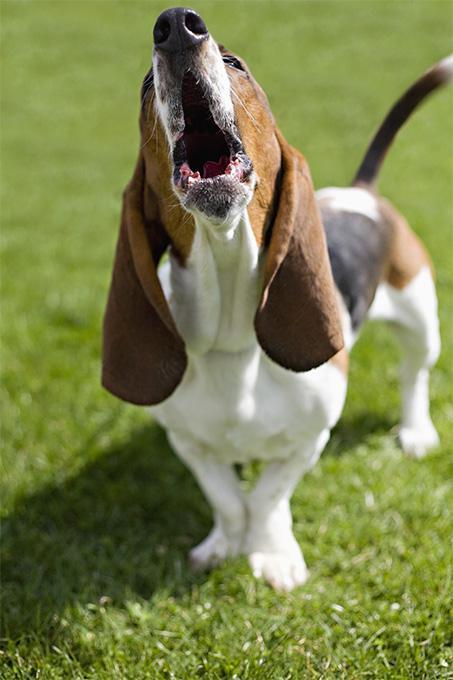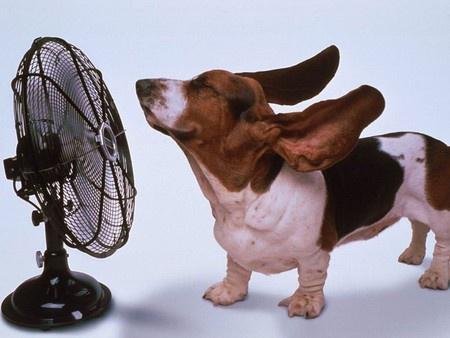The first image is the image on the left, the second image is the image on the right. Evaluate the accuracy of this statement regarding the images: "One dog is howling.". Is it true? Answer yes or no. Yes. The first image is the image on the left, the second image is the image on the right. For the images shown, is this caption "The left image shows a howling basset hound with its head raised straight up, and the right image includes a basset hound with its ears flying in the wind." true? Answer yes or no. Yes. 